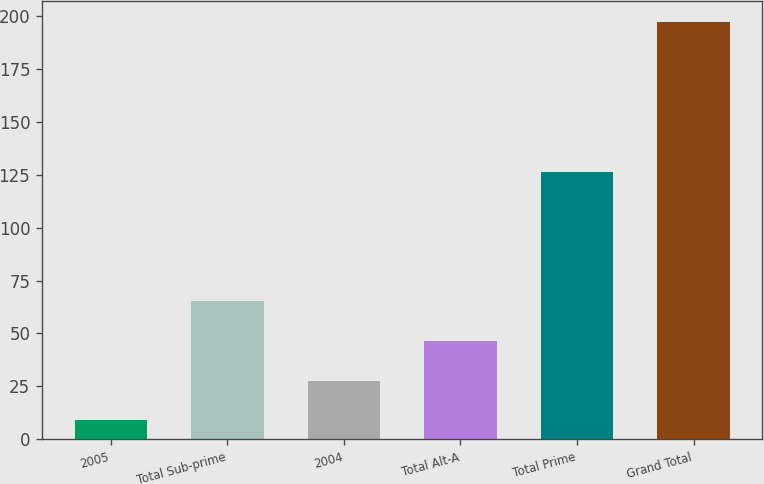<chart> <loc_0><loc_0><loc_500><loc_500><bar_chart><fcel>2005<fcel>Total Sub-prime<fcel>2004<fcel>Total Alt-A<fcel>Total Prime<fcel>Grand Total<nl><fcel>9<fcel>65.4<fcel>27.8<fcel>46.6<fcel>126<fcel>197<nl></chart> 